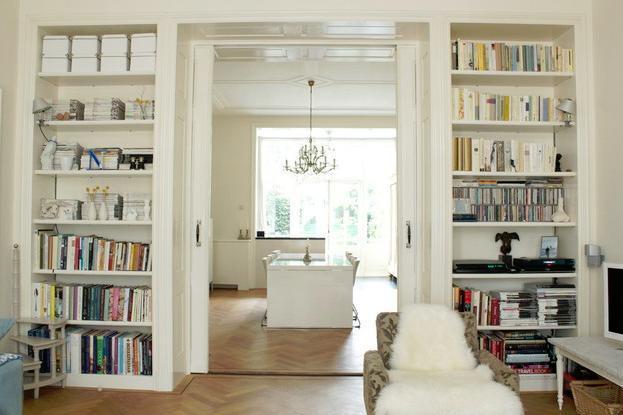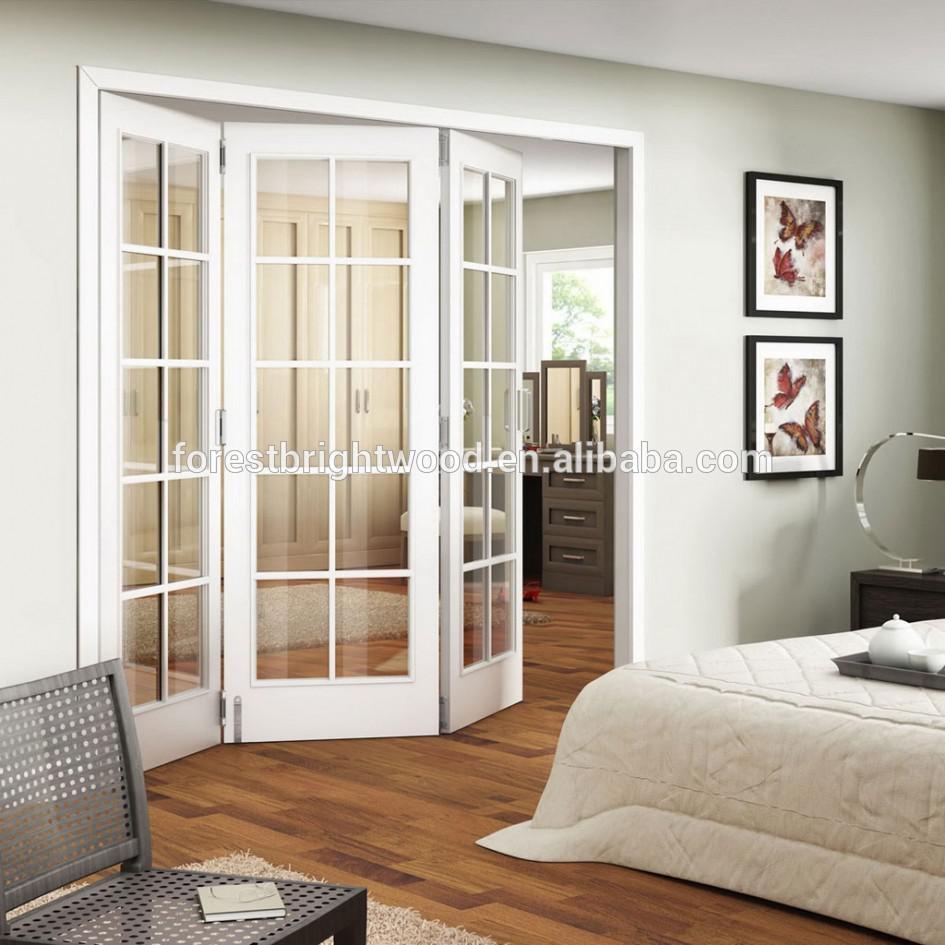The first image is the image on the left, the second image is the image on the right. Assess this claim about the two images: "An image shows a white room with tall white bookcases and something that opens into the next room and a facing window.". Correct or not? Answer yes or no. Yes. The first image is the image on the left, the second image is the image on the right. Considering the images on both sides, is "There is are three door windows separating two rooms with at least one painted white." valid? Answer yes or no. Yes. 